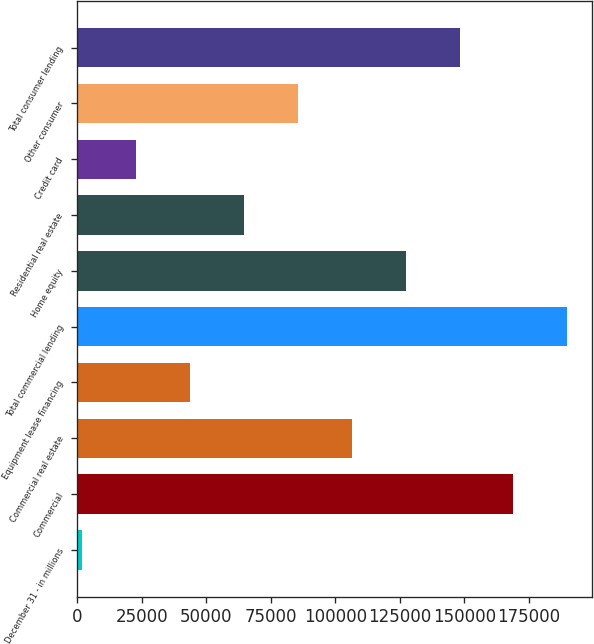Convert chart to OTSL. <chart><loc_0><loc_0><loc_500><loc_500><bar_chart><fcel>December 31 - in millions<fcel>Commercial<fcel>Commercial real estate<fcel>Equipment lease financing<fcel>Total commercial lending<fcel>Home equity<fcel>Residential real estate<fcel>Credit card<fcel>Other consumer<fcel>Total consumer lending<nl><fcel>2016<fcel>169070<fcel>106424<fcel>43779.4<fcel>189951<fcel>127306<fcel>64661.1<fcel>22897.7<fcel>85542.8<fcel>148188<nl></chart> 